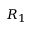<formula> <loc_0><loc_0><loc_500><loc_500>R _ { 1 }</formula> 